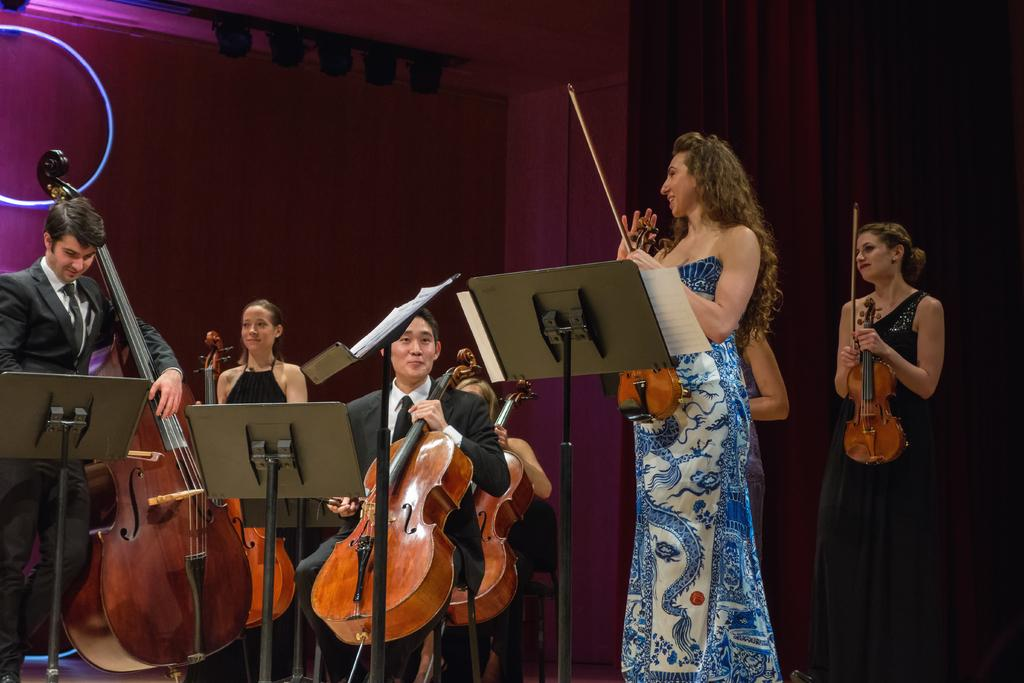What is hanging in the image? There is a curtain present in the image. What are the people in the image doing? The people in the image are holding guitars. Can you see your aunt playing the guitar with a dog in the image? There is no mention of an aunt or a dog in the image; it only features people holding guitars and a curtain. What type of rake is being used to play the guitar in the image? There is no rake present in the image; the people are holding guitars, not rakes. 